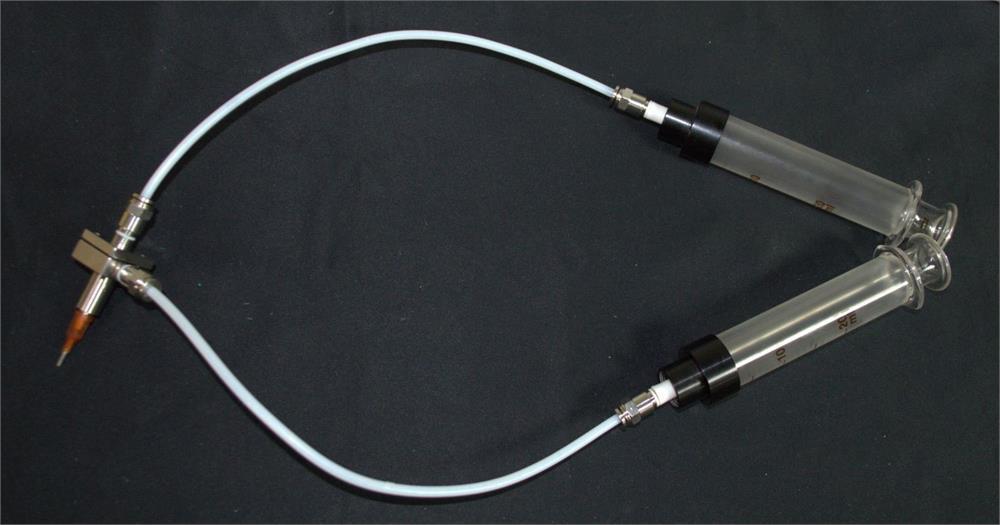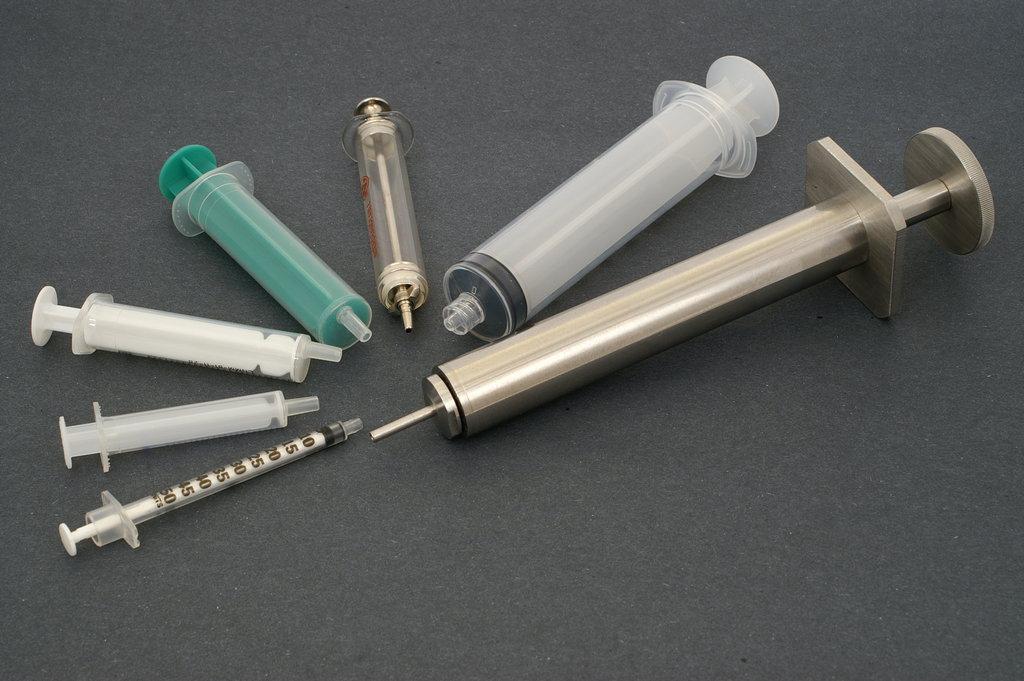The first image is the image on the left, the second image is the image on the right. For the images shown, is this caption "There is a white wire attached to all of the syringes in one of the images, and no wires in the other image." true? Answer yes or no. Yes. The first image is the image on the left, the second image is the image on the right. For the images displayed, is the sentence "there are syringes with tubing on them" factually correct? Answer yes or no. Yes. 